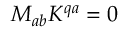<formula> <loc_0><loc_0><loc_500><loc_500>M _ { a b } K ^ { q a } = 0</formula> 